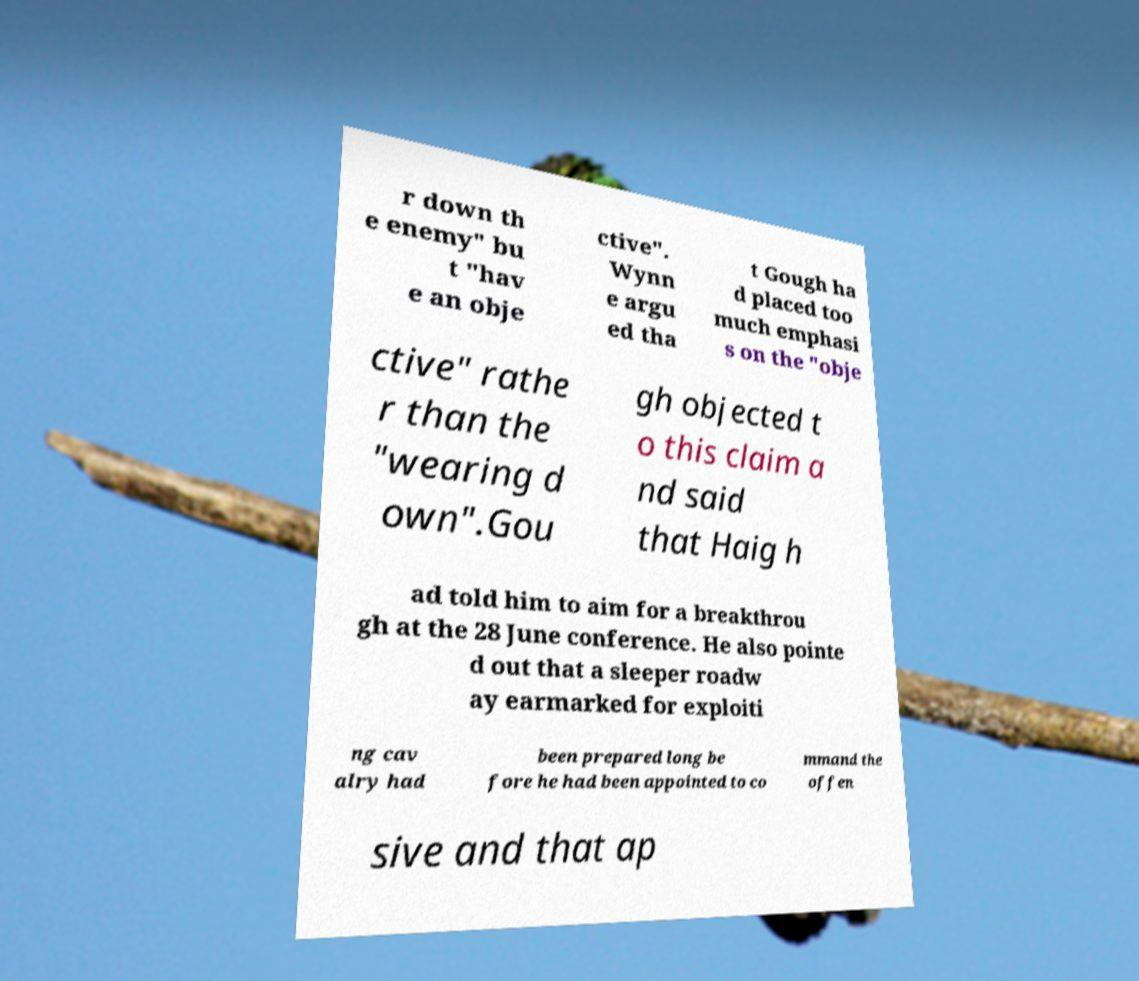Please read and relay the text visible in this image. What does it say? r down th e enemy" bu t "hav e an obje ctive". Wynn e argu ed tha t Gough ha d placed too much emphasi s on the "obje ctive" rathe r than the "wearing d own".Gou gh objected t o this claim a nd said that Haig h ad told him to aim for a breakthrou gh at the 28 June conference. He also pointe d out that a sleeper roadw ay earmarked for exploiti ng cav alry had been prepared long be fore he had been appointed to co mmand the offen sive and that ap 